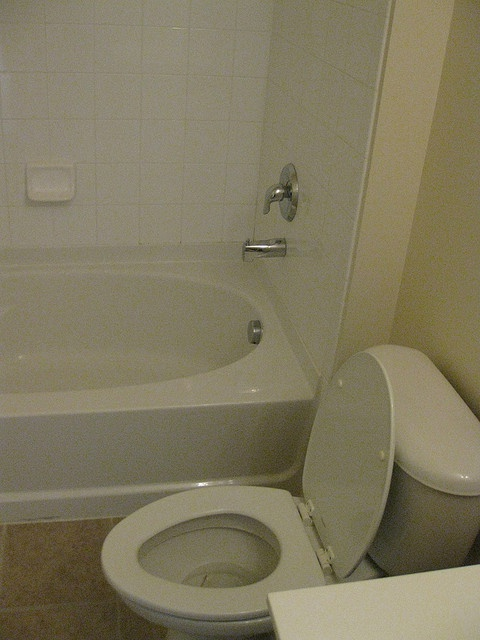Describe the objects in this image and their specific colors. I can see a toilet in olive, gray, darkgreen, and black tones in this image. 